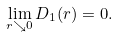<formula> <loc_0><loc_0><loc_500><loc_500>\lim _ { r \searrow 0 } D _ { 1 } ( r ) = 0 .</formula> 